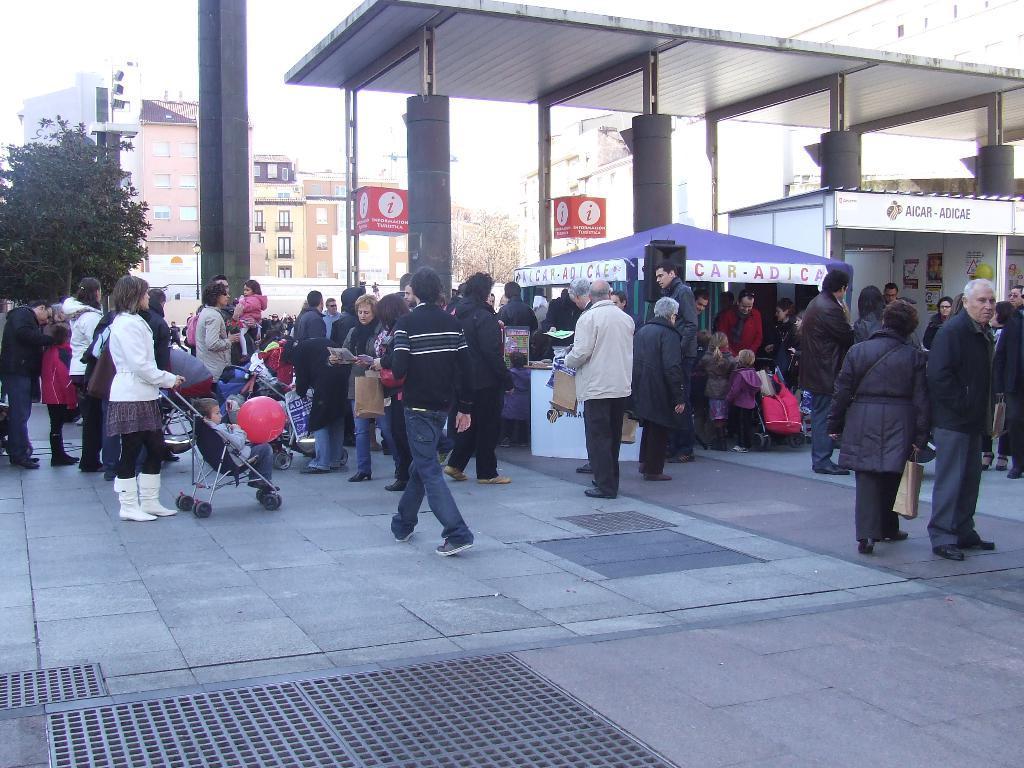Could you give a brief overview of what you see in this image? In this image there are group of persons, there are persons truncated towards the right of the image, there is a tree truncated towards the left of the image, there are buildings, there is a roof truncated towards the top of the image, there is a building truncated towards the top of the image, there are tents, there are boards, there is text on the boards and tents, there is an object truncated towards the right of the image, there is the sky truncated towards the top of the image. 